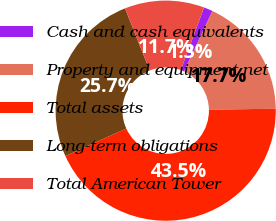<chart> <loc_0><loc_0><loc_500><loc_500><pie_chart><fcel>Cash and cash equivalents<fcel>Property and equipment net<fcel>Total assets<fcel>Long-term obligations<fcel>Total American Tower<nl><fcel>1.32%<fcel>17.72%<fcel>43.54%<fcel>25.73%<fcel>11.69%<nl></chart> 